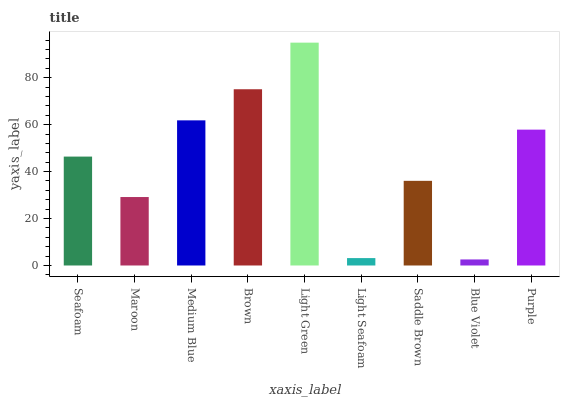Is Blue Violet the minimum?
Answer yes or no. Yes. Is Light Green the maximum?
Answer yes or no. Yes. Is Maroon the minimum?
Answer yes or no. No. Is Maroon the maximum?
Answer yes or no. No. Is Seafoam greater than Maroon?
Answer yes or no. Yes. Is Maroon less than Seafoam?
Answer yes or no. Yes. Is Maroon greater than Seafoam?
Answer yes or no. No. Is Seafoam less than Maroon?
Answer yes or no. No. Is Seafoam the high median?
Answer yes or no. Yes. Is Seafoam the low median?
Answer yes or no. Yes. Is Medium Blue the high median?
Answer yes or no. No. Is Blue Violet the low median?
Answer yes or no. No. 